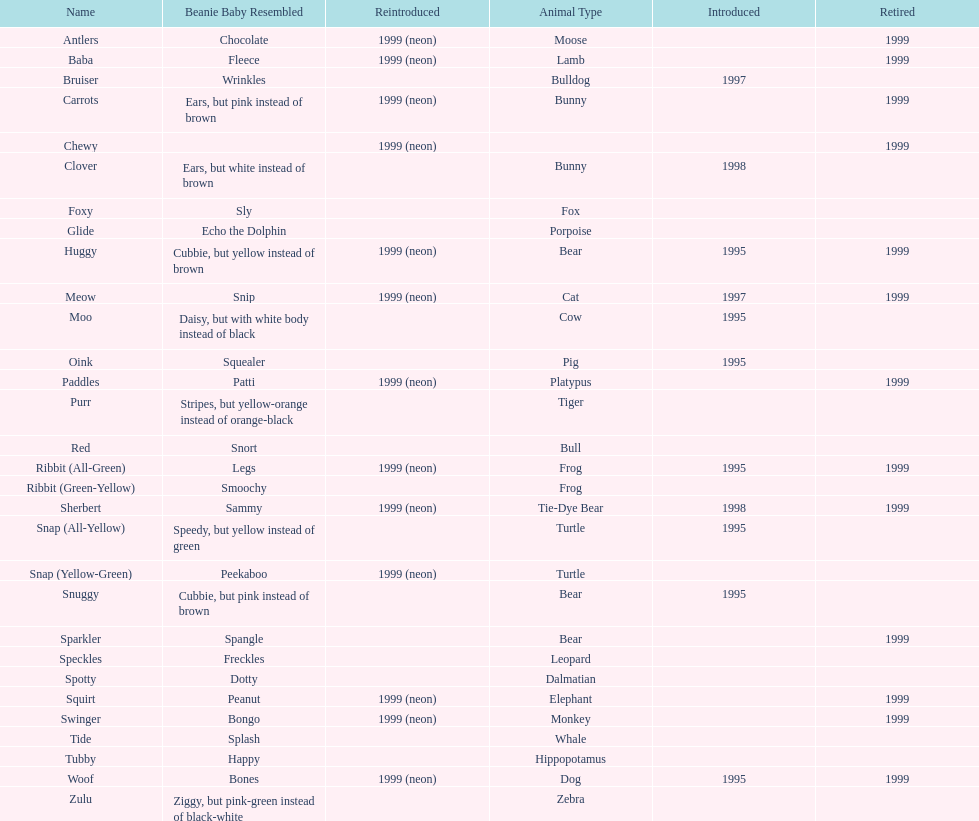Could you parse the entire table as a dict? {'header': ['Name', 'Beanie Baby Resembled', 'Reintroduced', 'Animal Type', 'Introduced', 'Retired'], 'rows': [['Antlers', 'Chocolate', '1999 (neon)', 'Moose', '', '1999'], ['Baba', 'Fleece', '1999 (neon)', 'Lamb', '', '1999'], ['Bruiser', 'Wrinkles', '', 'Bulldog', '1997', ''], ['Carrots', 'Ears, but pink instead of brown', '1999 (neon)', 'Bunny', '', '1999'], ['Chewy', '', '1999 (neon)', '', '', '1999'], ['Clover', 'Ears, but white instead of brown', '', 'Bunny', '1998', ''], ['Foxy', 'Sly', '', 'Fox', '', ''], ['Glide', 'Echo the Dolphin', '', 'Porpoise', '', ''], ['Huggy', 'Cubbie, but yellow instead of brown', '1999 (neon)', 'Bear', '1995', '1999'], ['Meow', 'Snip', '1999 (neon)', 'Cat', '1997', '1999'], ['Moo', 'Daisy, but with white body instead of black', '', 'Cow', '1995', ''], ['Oink', 'Squealer', '', 'Pig', '1995', ''], ['Paddles', 'Patti', '1999 (neon)', 'Platypus', '', '1999'], ['Purr', 'Stripes, but yellow-orange instead of orange-black', '', 'Tiger', '', ''], ['Red', 'Snort', '', 'Bull', '', ''], ['Ribbit (All-Green)', 'Legs', '1999 (neon)', 'Frog', '1995', '1999'], ['Ribbit (Green-Yellow)', 'Smoochy', '', 'Frog', '', ''], ['Sherbert', 'Sammy', '1999 (neon)', 'Tie-Dye Bear', '1998', '1999'], ['Snap (All-Yellow)', 'Speedy, but yellow instead of green', '', 'Turtle', '1995', ''], ['Snap (Yellow-Green)', 'Peekaboo', '1999 (neon)', 'Turtle', '', ''], ['Snuggy', 'Cubbie, but pink instead of brown', '', 'Bear', '1995', ''], ['Sparkler', 'Spangle', '', 'Bear', '', '1999'], ['Speckles', 'Freckles', '', 'Leopard', '', ''], ['Spotty', 'Dotty', '', 'Dalmatian', '', ''], ['Squirt', 'Peanut', '1999 (neon)', 'Elephant', '', '1999'], ['Swinger', 'Bongo', '1999 (neon)', 'Monkey', '', '1999'], ['Tide', 'Splash', '', 'Whale', '', ''], ['Tubby', 'Happy', '', 'Hippopotamus', '', ''], ['Woof', 'Bones', '1999 (neon)', 'Dog', '1995', '1999'], ['Zulu', 'Ziggy, but pink-green instead of black-white', '', 'Zebra', '', '']]} What is the total number of pillow pals that were reintroduced as a neon variety? 13. 